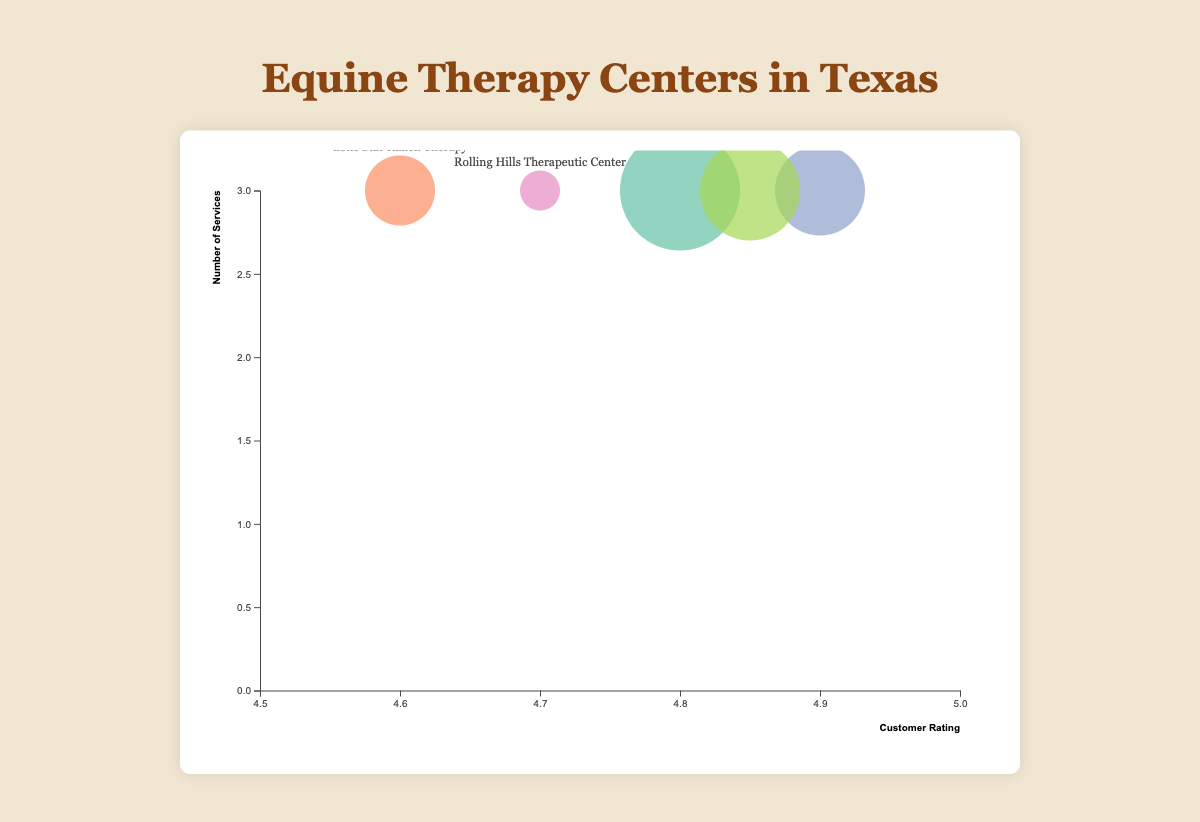Which Equine Therapy Center has the highest customer rating? Look for the bubble with the highest position along the "Customer Rating" axis. The highest rating is 4.9.
Answer: Texas Equine Associates Which center provides the fewest services? Count the number of services offered by each center by observing their vertical position on the y-axis. The bubble lowest on the y-axis offers the fewest services, which is 3 services.
Answer: Rolling Hills Therapeutic Center How many services does Skyline Ranch Therapy Center provide? Find the "Skyline Ranch Therapy Center" label on the bubbles and check its y-axis position. It corresponds to 3 services.
Answer: 3 services Which center has the most reviews, and how many are there? Look for the bubble with the largest size, indicating the number of reviews. The largest bubble corresponds to the most reviews.
Answer: Blue Ridge Equine Center, 120 reviews What is the average customer rating of all the centers combined? Add all the customer ratings (4.8, 4.6, 4.9, 4.7, 4.85), then divide by the number of centers, which is 5.
Answer: 4.77 Which center provides the most services with a rating above 4.7? First, identify which centers have ratings above 4.7. Then, compare the vertical positions of these bubbles. The highest bubble corresponds to the most services.
Answer: Texas Equine Associates Are there any centers that offer the same number of services but have different customer ratings? Compare the y-axis positions of the bubbles to see if any align horizontally but differ vertically along the x-axis.
Answer: Yes, Blue Ridge Equine Center and Lone Star Ranch Therapy Which center with customer ratings between 4.6 and 4.7 has the highest number of reviews? Identify bubbles within the 4.6 to 4.7 rating range on the x-axis. Compare the size of these bubbles to find the largest.
Answer: Rolling Hills Therapeutic Center, 80 reviews What is the total number of reviews for all centers combined? Add the number of reviews for each center: 120 + 95 + 105 + 80 + 110.
Answer: 510 reviews 